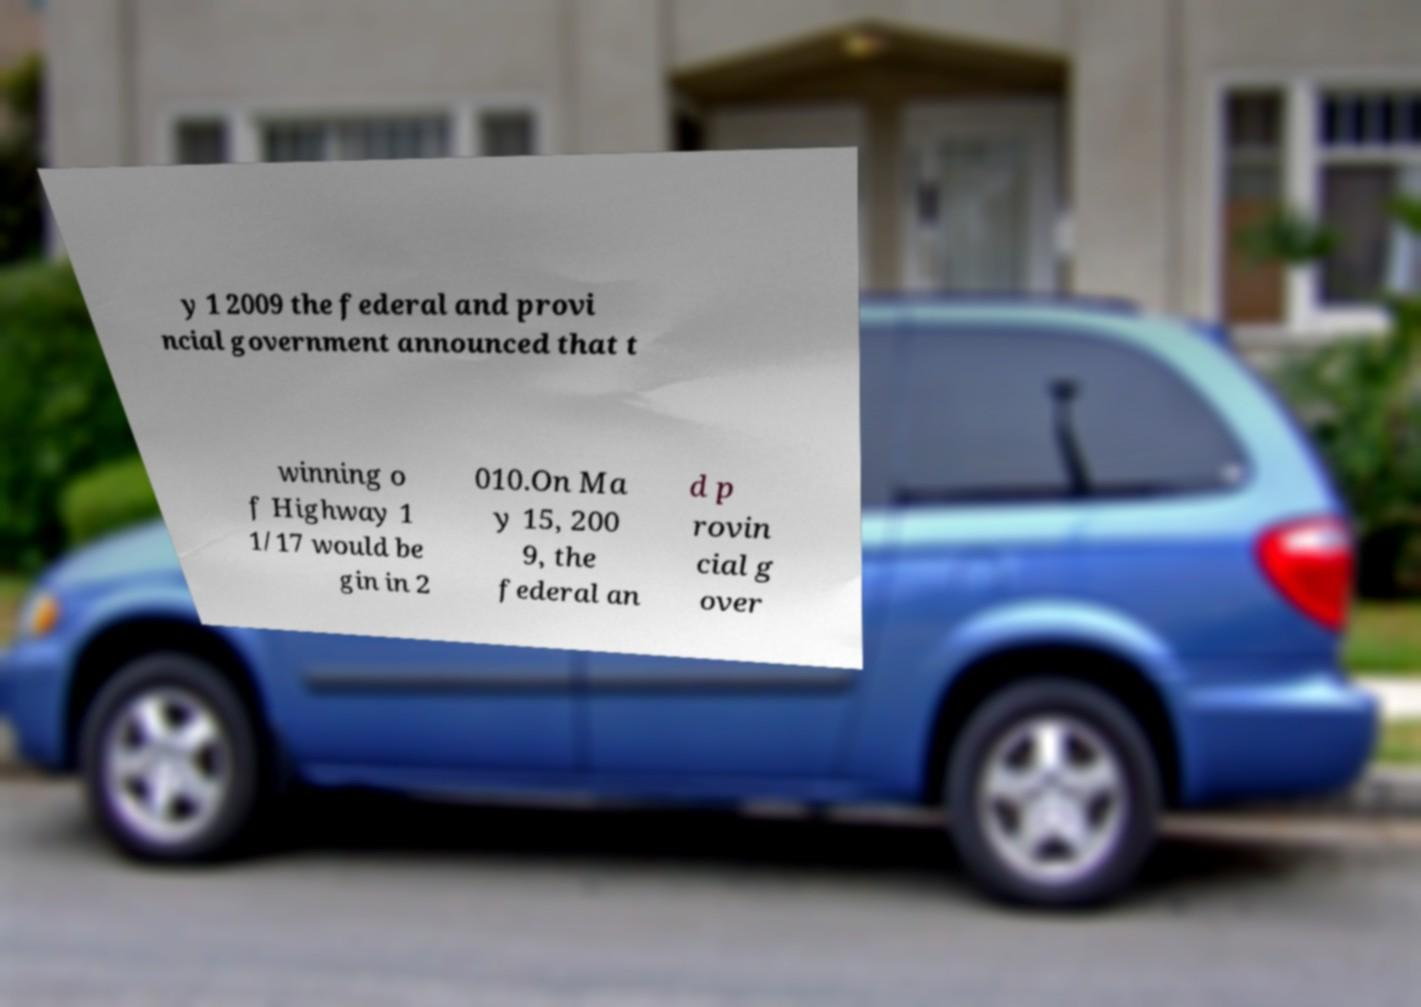Can you read and provide the text displayed in the image?This photo seems to have some interesting text. Can you extract and type it out for me? y 1 2009 the federal and provi ncial government announced that t winning o f Highway 1 1/17 would be gin in 2 010.On Ma y 15, 200 9, the federal an d p rovin cial g over 